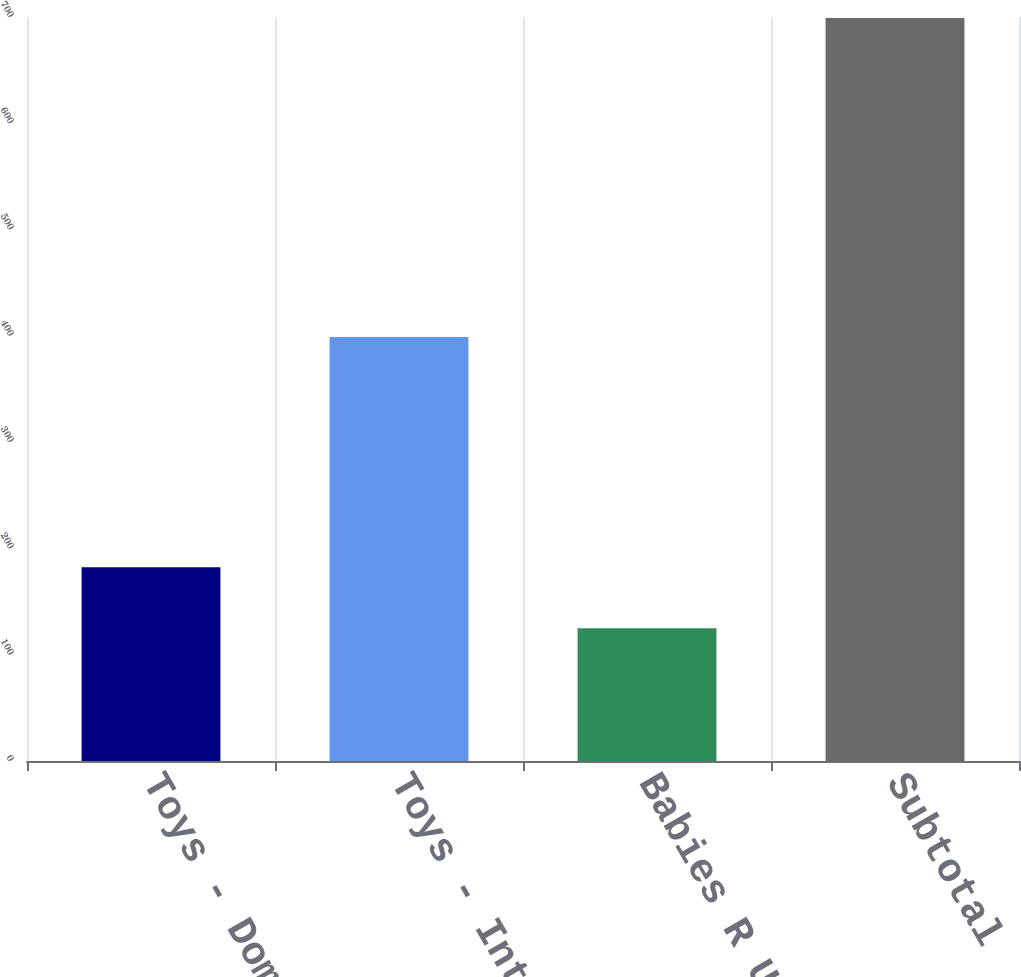Convert chart to OTSL. <chart><loc_0><loc_0><loc_500><loc_500><bar_chart><fcel>Toys - Domestic<fcel>Toys - International<fcel>Babies R Us<fcel>Subtotal<nl><fcel>182.4<fcel>399<fcel>125<fcel>699<nl></chart> 